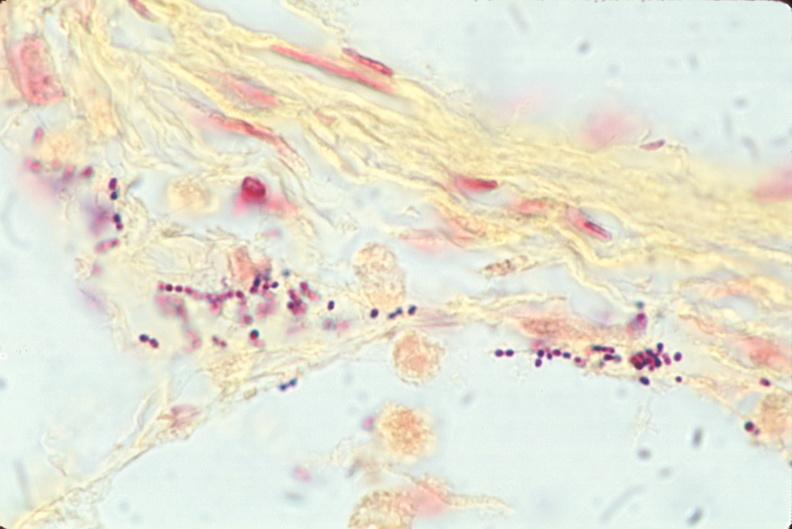what stain?
Answer the question using a single word or phrase. This image shows lung 